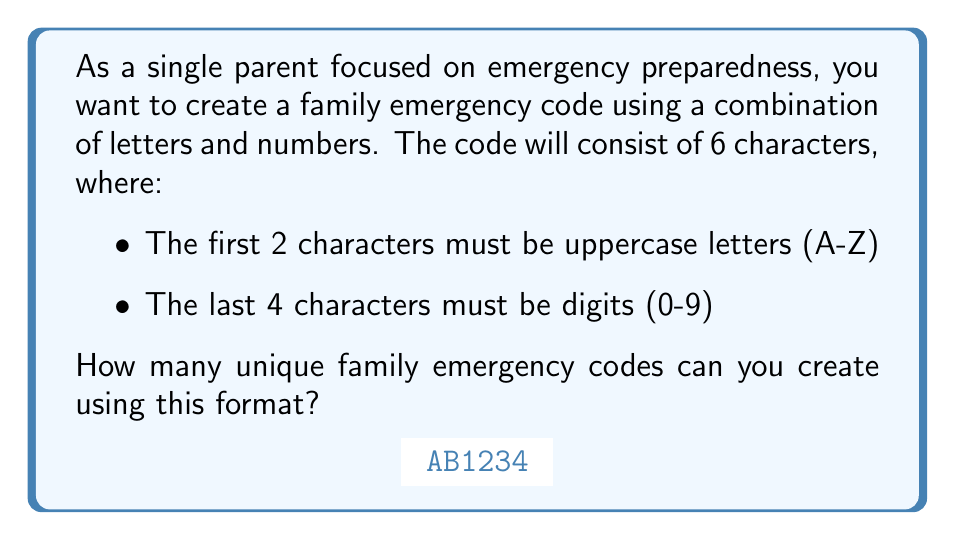Provide a solution to this math problem. Let's break this down step-by-step:

1) For the first two characters (uppercase letters):
   - There are 26 choices for each letter
   - We can use the multiplication principle: $26 \times 26 = 26^2$

2) For the last four characters (digits):
   - There are 10 choices (0-9) for each digit
   - Again, using the multiplication principle: $10 \times 10 \times 10 \times 10 = 10^4$

3) To find the total number of combinations, we multiply the number of possibilities for each part:

   $$\text{Total combinations} = 26^2 \times 10^4$$

4) Let's calculate this:
   $$26^2 = 676$$
   $$10^4 = 10,000$$
   $$676 \times 10,000 = 6,760,000$$

Therefore, there are 6,760,000 possible unique family emergency codes that can be created using this format.
Answer: $6,760,000$ 